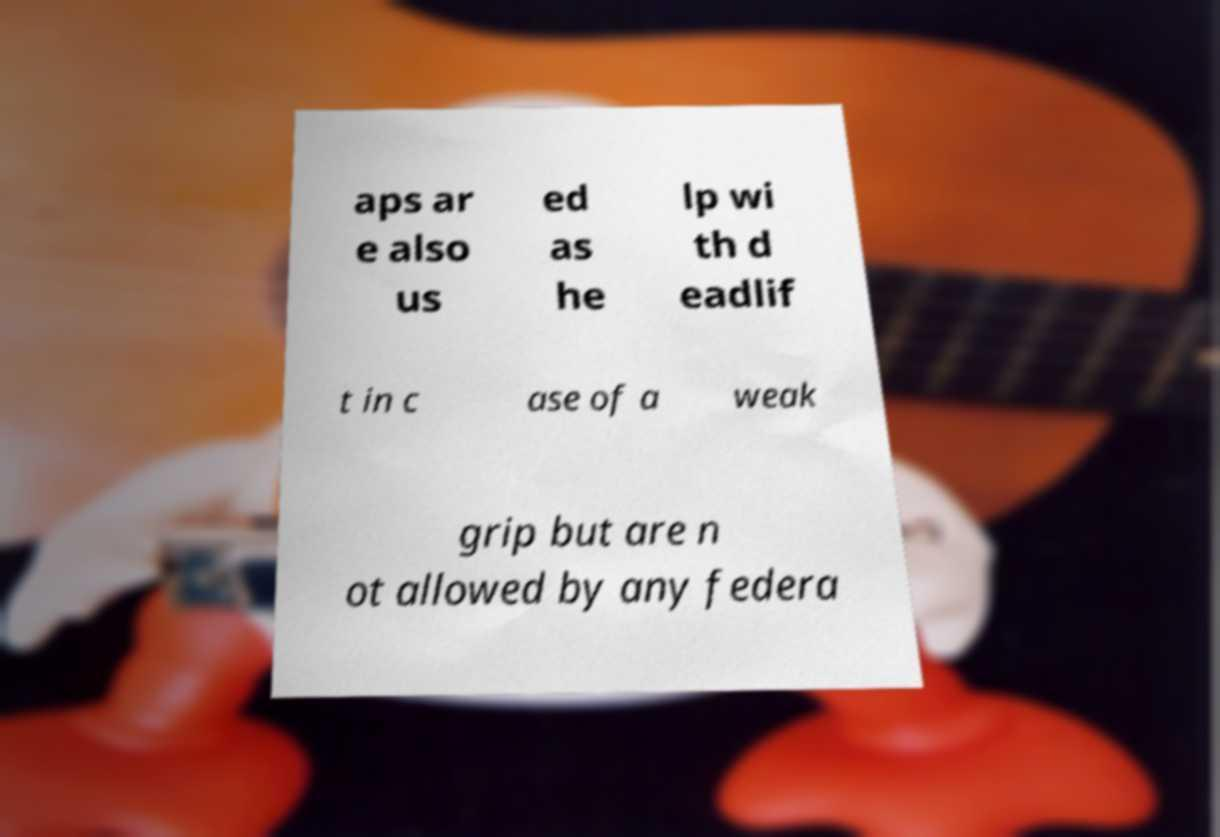For documentation purposes, I need the text within this image transcribed. Could you provide that? aps ar e also us ed as he lp wi th d eadlif t in c ase of a weak grip but are n ot allowed by any federa 